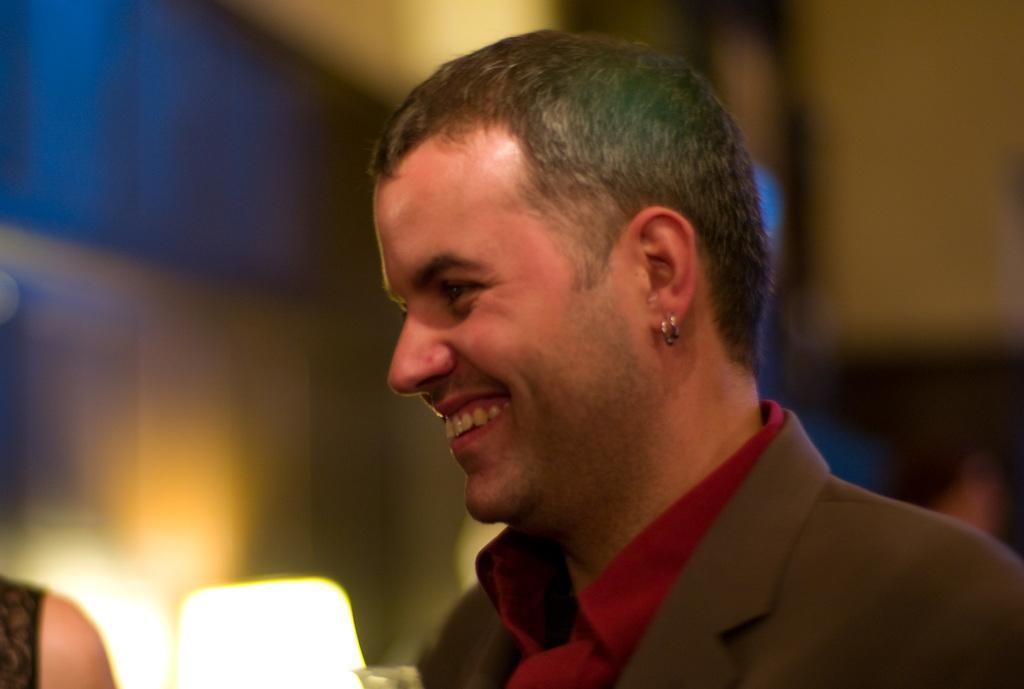In one or two sentences, can you explain what this image depicts? In the foreground of the picture there is a person smiling. In the center there is lamp. On the left there is a person's shoulder. The background is blurred. 